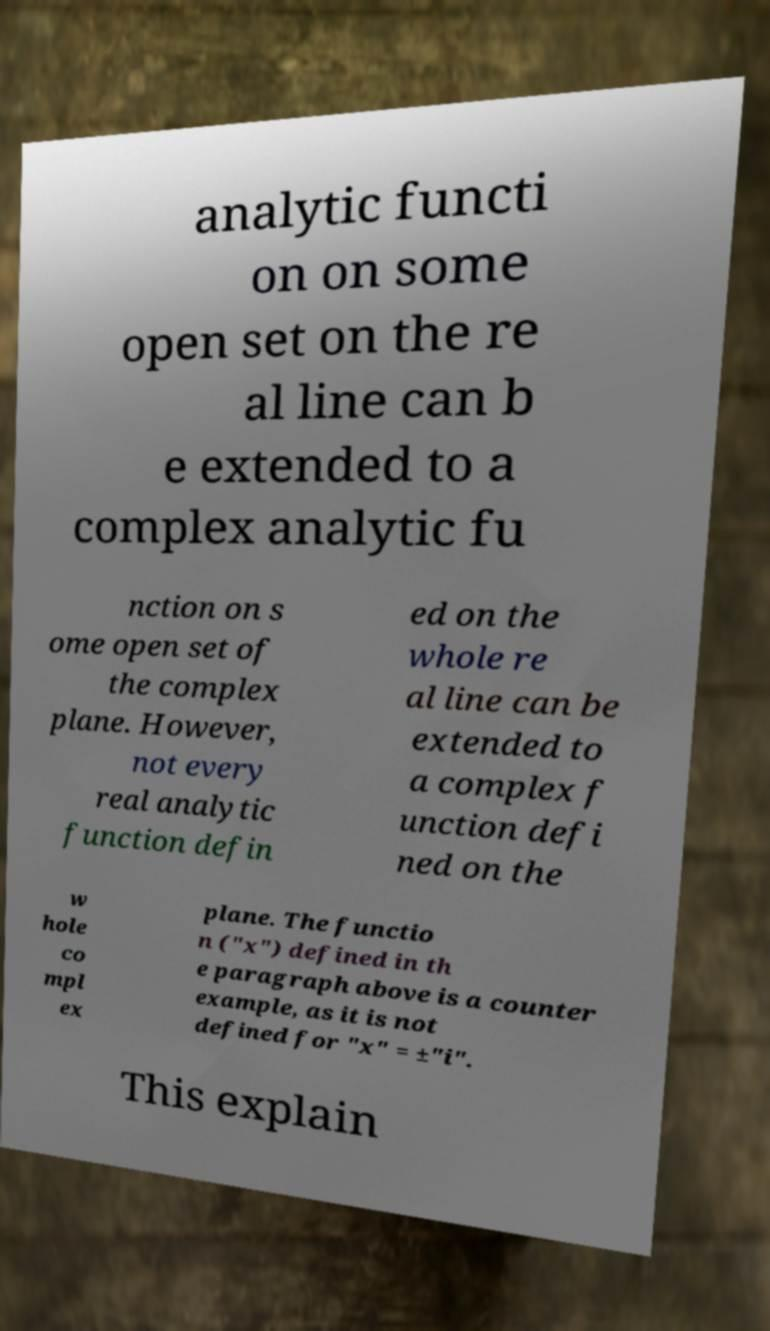There's text embedded in this image that I need extracted. Can you transcribe it verbatim? analytic functi on on some open set on the re al line can b e extended to a complex analytic fu nction on s ome open set of the complex plane. However, not every real analytic function defin ed on the whole re al line can be extended to a complex f unction defi ned on the w hole co mpl ex plane. The functio n ("x") defined in th e paragraph above is a counter example, as it is not defined for "x" = ±"i". This explain 